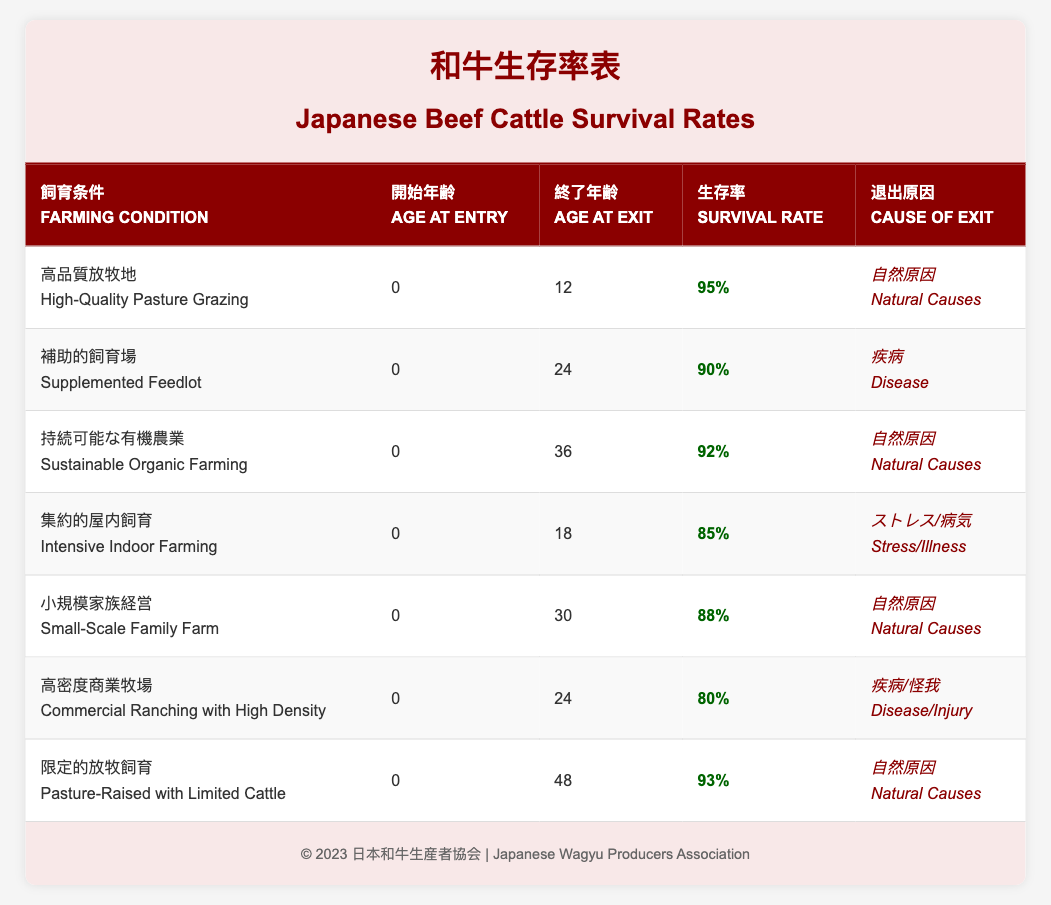What is the survival rate for cattle in High-Quality Pasture Grazing? The table shows that in High-Quality Pasture Grazing, the survival rate is specifically listed as 95%.
Answer: 95% How old are cattle when they exit the Intensive Indoor Farming condition? According to the table, cattle exit Intensive Indoor Farming at the age of 18 months.
Answer: 18 What is the cause of exit for cattle raised in Supplemented Feedlot? The table specifies that the cause of exit for cattle in a Supplemented Feedlot is due to Disease.
Answer: Disease Which farming condition has the highest survival rate? By comparing the survival rates, High-Quality Pasture Grazing has the highest survival rate of 95%.
Answer: High-Quality Pasture Grazing What is the average survival rate across all farming conditions listed in the table? To find the average survival rate, add the survival rates (95 + 90 + 92 + 85 + 88 + 80 + 93 = 623) and divide by the number of conditions (7). Therefore, the average is 623/7 = 89. Therefore, the average survival rate is approximately 89%.
Answer: 89% Is the survival rate for Commercial Ranching with High Density higher than for Small-Scale Family Farm? The survival rate for Commercial Ranching with High Density is 80%, while the Small-Scale Family Farm has a survival rate of 88%. Since 80% is not greater than 88%, the statement is false.
Answer: No What is the difference in survival rate between Pasture-Raised with Limited Cattle and Intensive Indoor Farming? The survival rate for Pasture-Raised with Limited Cattle is 93% and for Intensive Indoor Farming it is 85%. The difference is calculated as 93 - 85 = 8%.
Answer: 8% Which farming condition shows the lowest survival rate and what is the cause of exit? The data reveals that the farming condition with the lowest survival rate is Commercial Ranching with High Density, which has a survival rate of 80%. The cause of exit is listed as Disease/Injury.
Answer: Commercial Ranching with High Density; Disease/Injury Do all farming conditions have a survival rate of at least 80%? Checking the table indicates that all listed farming conditions have survival rates of 80% or higher: 95%, 90%, 92%, 85%, 88%, 80%, and 93%. Thus, the answer is yes.
Answer: Yes 